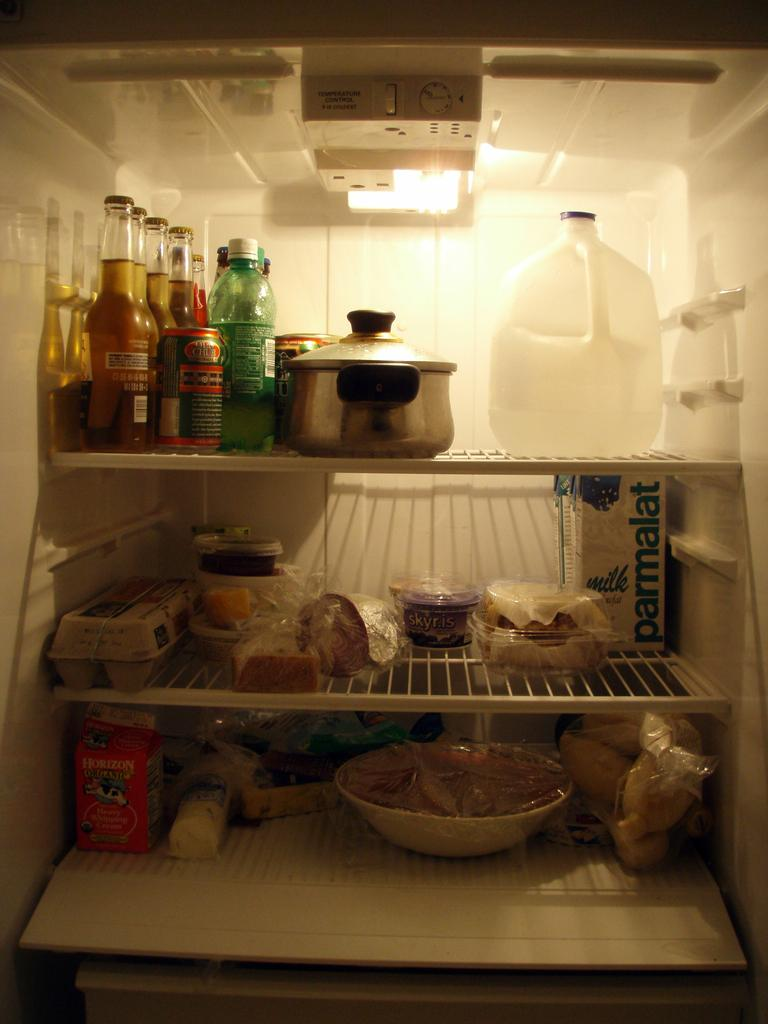What is the main subject of the image? The main subject of the image is a refrigerator. What types of items can be seen inside the refrigerator? There are bottles, covers, bowls, and a can on the trays in the image. What is the source of light in the image? There is a light at the top of the image. Is there any control or feature visible at the top of the image? Yes, there is a button at the top of the image. How many men are riding bikes in the image? There are no men or bikes present in the image; it is a picture of a refrigerator. What type of writing can be seen on the refrigerator door in the image? There is no writing visible on the refrigerator door in the image. 